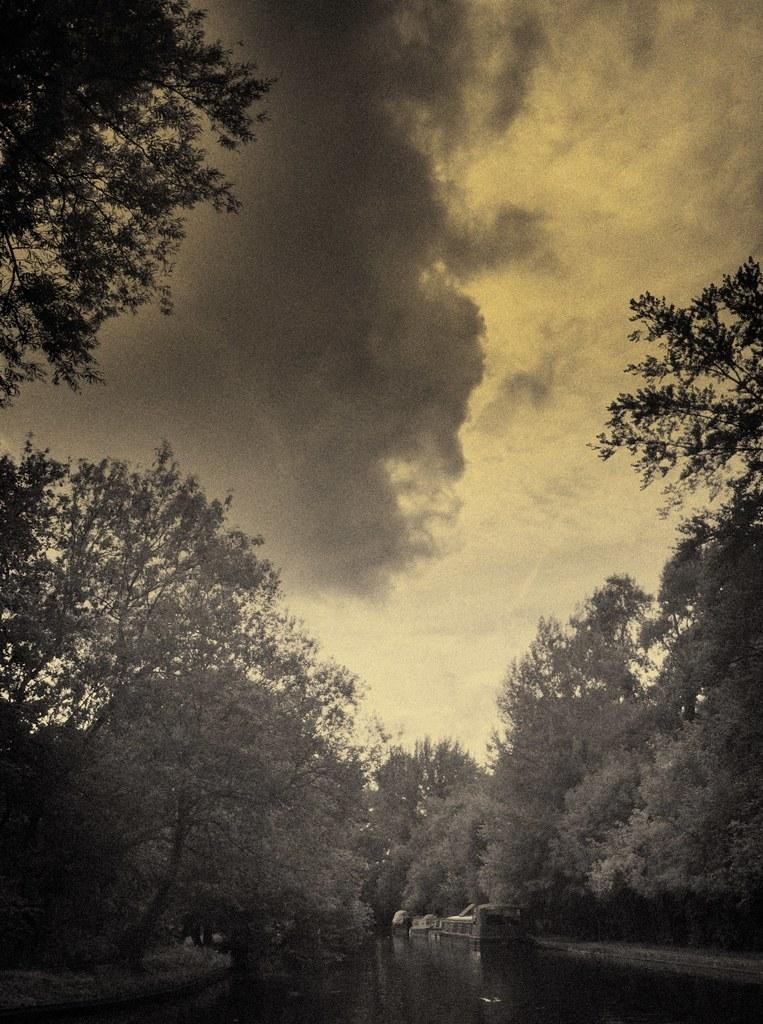What type of vegetation can be seen in the image? There are trees in the image. What is visible at the top of the image? The sky is visible at the top of the image. What can be seen in the sky? There are clouds in the sky. Can you describe the water in the image? There might be a boat on the water at the bottom of the image. What is the caption for the image? There is no caption present in the image. Can you tell me how many fangs are visible on the trees in the image? There are no fangs present on the trees in the image; they are regular trees. 